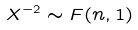Convert formula to latex. <formula><loc_0><loc_0><loc_500><loc_500>X ^ { - 2 } \sim F ( n , 1 )</formula> 